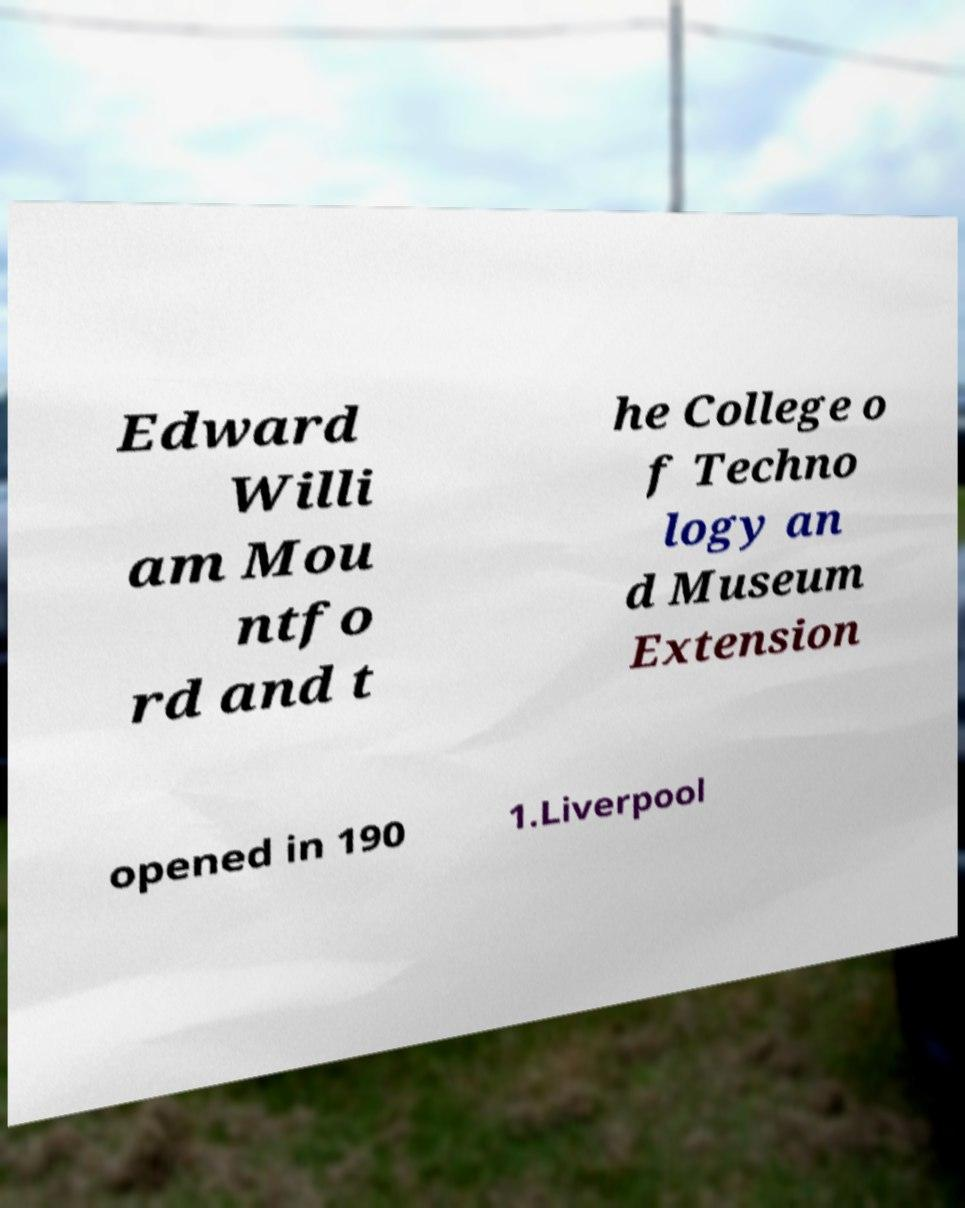Please identify and transcribe the text found in this image. Edward Willi am Mou ntfo rd and t he College o f Techno logy an d Museum Extension opened in 190 1.Liverpool 